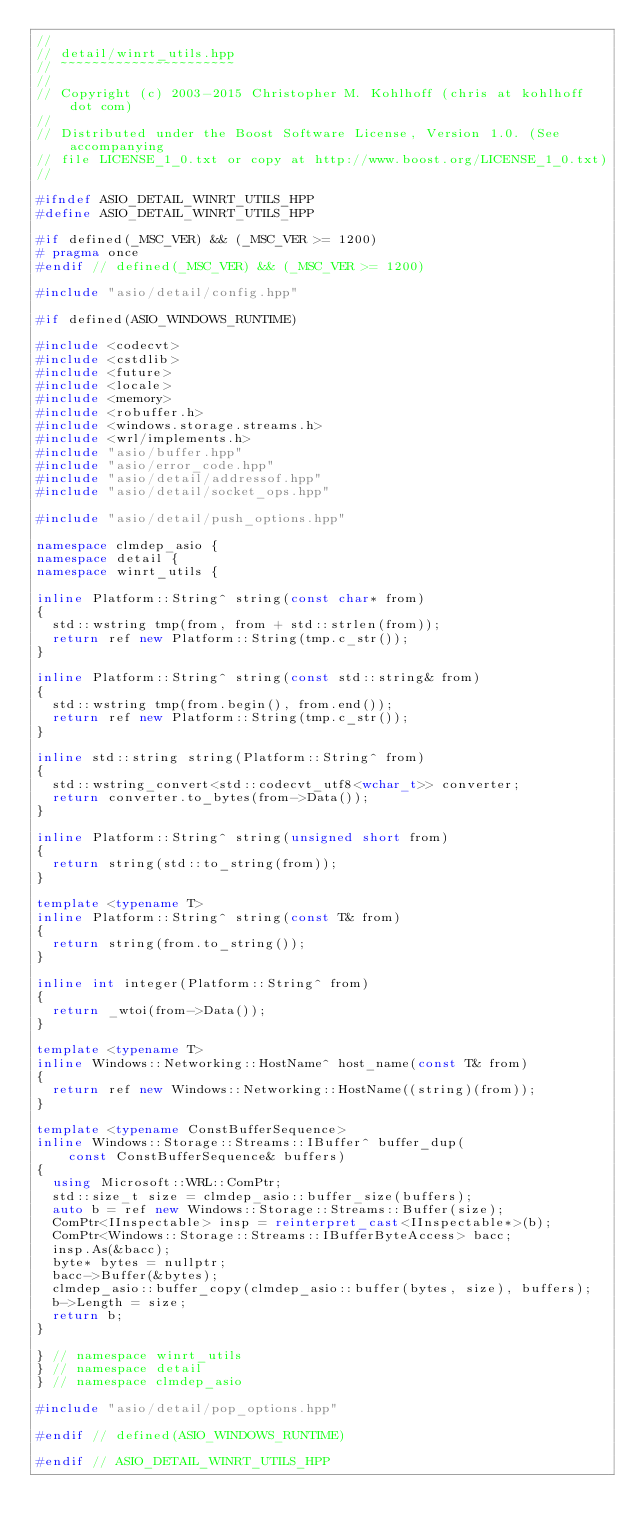Convert code to text. <code><loc_0><loc_0><loc_500><loc_500><_C++_>//
// detail/winrt_utils.hpp
// ~~~~~~~~~~~~~~~~~~~~~~
//
// Copyright (c) 2003-2015 Christopher M. Kohlhoff (chris at kohlhoff dot com)
//
// Distributed under the Boost Software License, Version 1.0. (See accompanying
// file LICENSE_1_0.txt or copy at http://www.boost.org/LICENSE_1_0.txt)
//

#ifndef ASIO_DETAIL_WINRT_UTILS_HPP
#define ASIO_DETAIL_WINRT_UTILS_HPP

#if defined(_MSC_VER) && (_MSC_VER >= 1200)
# pragma once
#endif // defined(_MSC_VER) && (_MSC_VER >= 1200)

#include "asio/detail/config.hpp"

#if defined(ASIO_WINDOWS_RUNTIME)

#include <codecvt>
#include <cstdlib>
#include <future>
#include <locale>
#include <memory>
#include <robuffer.h>
#include <windows.storage.streams.h>
#include <wrl/implements.h>
#include "asio/buffer.hpp"
#include "asio/error_code.hpp"
#include "asio/detail/addressof.hpp"
#include "asio/detail/socket_ops.hpp"

#include "asio/detail/push_options.hpp"

namespace clmdep_asio {
namespace detail {
namespace winrt_utils {

inline Platform::String^ string(const char* from)
{
  std::wstring tmp(from, from + std::strlen(from));
  return ref new Platform::String(tmp.c_str());
}

inline Platform::String^ string(const std::string& from)
{
  std::wstring tmp(from.begin(), from.end());
  return ref new Platform::String(tmp.c_str());
}

inline std::string string(Platform::String^ from)
{
  std::wstring_convert<std::codecvt_utf8<wchar_t>> converter;
  return converter.to_bytes(from->Data());
}

inline Platform::String^ string(unsigned short from)
{
  return string(std::to_string(from));
}

template <typename T>
inline Platform::String^ string(const T& from)
{
  return string(from.to_string());
}

inline int integer(Platform::String^ from)
{
  return _wtoi(from->Data());
}

template <typename T>
inline Windows::Networking::HostName^ host_name(const T& from)
{
  return ref new Windows::Networking::HostName((string)(from));
}

template <typename ConstBufferSequence>
inline Windows::Storage::Streams::IBuffer^ buffer_dup(
    const ConstBufferSequence& buffers)
{
  using Microsoft::WRL::ComPtr;
  std::size_t size = clmdep_asio::buffer_size(buffers);
  auto b = ref new Windows::Storage::Streams::Buffer(size);
  ComPtr<IInspectable> insp = reinterpret_cast<IInspectable*>(b);
  ComPtr<Windows::Storage::Streams::IBufferByteAccess> bacc;
  insp.As(&bacc);
  byte* bytes = nullptr;
  bacc->Buffer(&bytes);
  clmdep_asio::buffer_copy(clmdep_asio::buffer(bytes, size), buffers);
  b->Length = size;
  return b;
}

} // namespace winrt_utils
} // namespace detail
} // namespace clmdep_asio

#include "asio/detail/pop_options.hpp"

#endif // defined(ASIO_WINDOWS_RUNTIME)

#endif // ASIO_DETAIL_WINRT_UTILS_HPP
</code> 